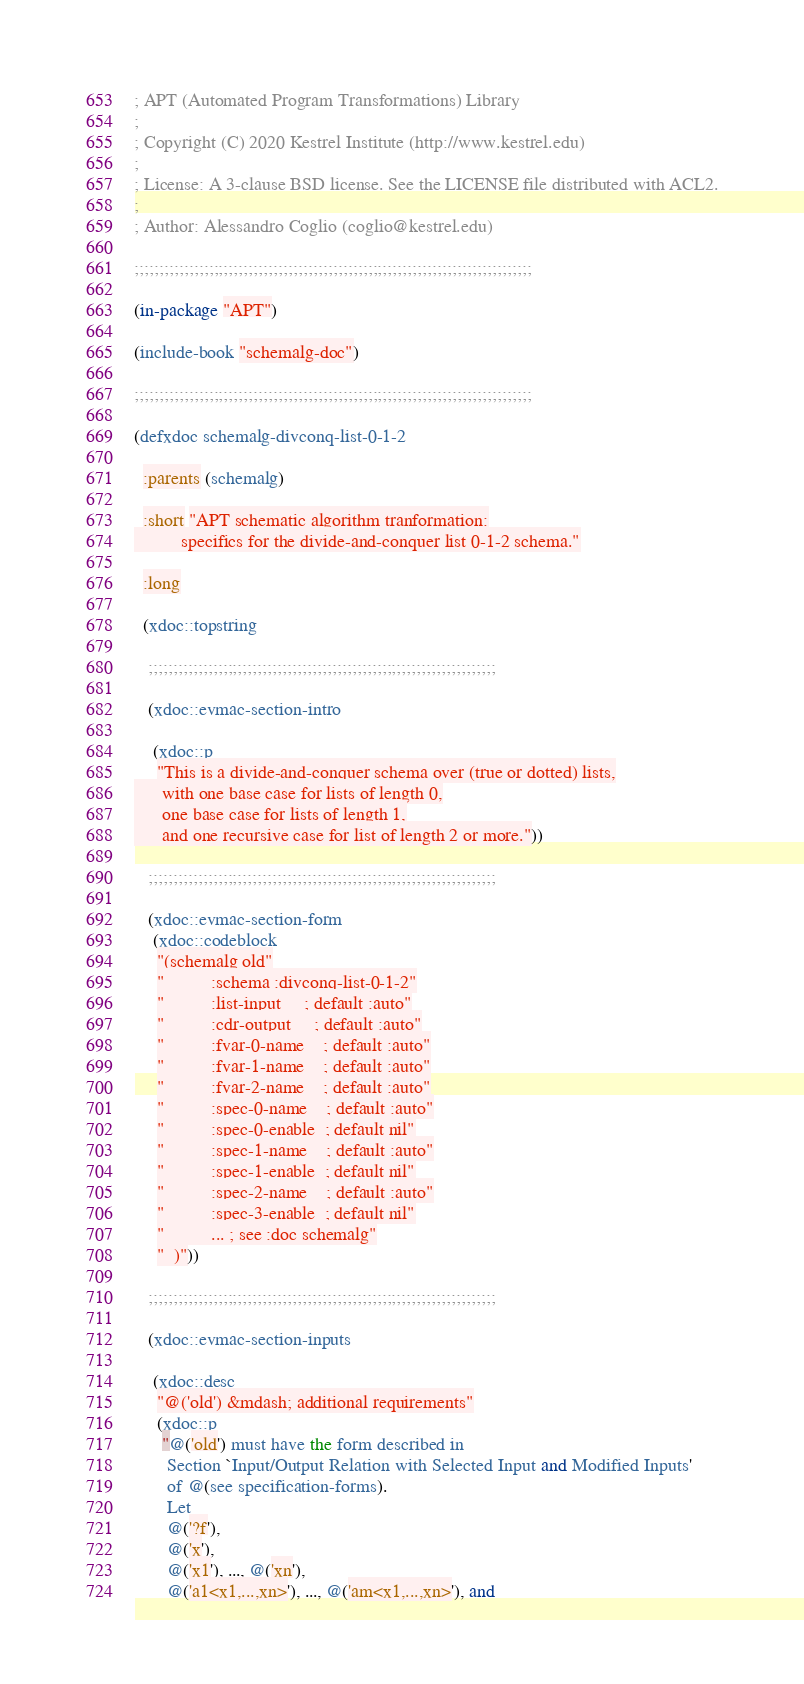<code> <loc_0><loc_0><loc_500><loc_500><_Lisp_>; APT (Automated Program Transformations) Library
;
; Copyright (C) 2020 Kestrel Institute (http://www.kestrel.edu)
;
; License: A 3-clause BSD license. See the LICENSE file distributed with ACL2.
;
; Author: Alessandro Coglio (coglio@kestrel.edu)

;;;;;;;;;;;;;;;;;;;;;;;;;;;;;;;;;;;;;;;;;;;;;;;;;;;;;;;;;;;;;;;;;;;;;;;;;;;;;;;;

(in-package "APT")

(include-book "schemalg-doc")

;;;;;;;;;;;;;;;;;;;;;;;;;;;;;;;;;;;;;;;;;;;;;;;;;;;;;;;;;;;;;;;;;;;;;;;;;;;;;;;;

(defxdoc schemalg-divconq-list-0-1-2

  :parents (schemalg)

  :short "APT schematic algorithm tranformation:
          specifics for the divide-and-conquer list 0-1-2 schema."

  :long

  (xdoc::topstring

   ;;;;;;;;;;;;;;;;;;;;;;;;;;;;;;;;;;;;;;;;;;;;;;;;;;;;;;;;;;;;;;;;;;;;;;

   (xdoc::evmac-section-intro

    (xdoc::p
     "This is a divide-and-conquer schema over (true or dotted) lists,
      with one base case for lists of length 0,
      one base case for lists of length 1,
      and one recursive case for list of length 2 or more."))

   ;;;;;;;;;;;;;;;;;;;;;;;;;;;;;;;;;;;;;;;;;;;;;;;;;;;;;;;;;;;;;;;;;;;;;;

   (xdoc::evmac-section-form
    (xdoc::codeblock
     "(schemalg old"
     "          :schema :divconq-list-0-1-2"
     "          :list-input     ; default :auto"
     "          :cdr-output     ; default :auto"
     "          :fvar-0-name    ; default :auto"
     "          :fvar-1-name    ; default :auto"
     "          :fvar-2-name    ; default :auto"
     "          :spec-0-name    ; default :auto"
     "          :spec-0-enable  ; default nil"
     "          :spec-1-name    ; default :auto"
     "          :spec-1-enable  ; default nil"
     "          :spec-2-name    ; default :auto"
     "          :spec-3-enable  ; default nil"
     "          ... ; see :doc schemalg"
     "  )"))

   ;;;;;;;;;;;;;;;;;;;;;;;;;;;;;;;;;;;;;;;;;;;;;;;;;;;;;;;;;;;;;;;;;;;;;;

   (xdoc::evmac-section-inputs

    (xdoc::desc
     "@('old') &mdash; additional requirements"
     (xdoc::p
      "@('old') must have the form described in
       Section `Input/Output Relation with Selected Input and Modified Inputs'
       of @(see specification-forms).
       Let
       @('?f'),
       @('x'),
       @('x1'), ..., @('xn'),
       @('a1<x1,...,xn>'), ..., @('am<x1,...,xn>'), and</code> 